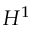<formula> <loc_0><loc_0><loc_500><loc_500>H ^ { 1 }</formula> 